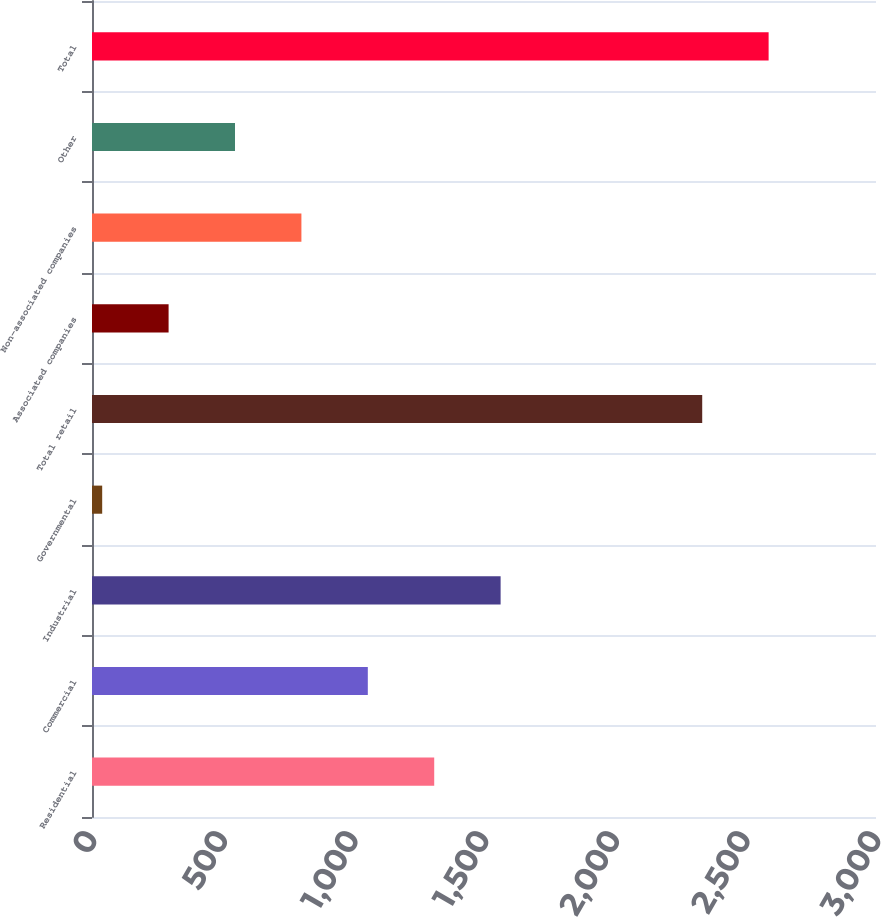<chart> <loc_0><loc_0><loc_500><loc_500><bar_chart><fcel>Residential<fcel>Commercial<fcel>Industrial<fcel>Governmental<fcel>Total retail<fcel>Associated companies<fcel>Non-associated companies<fcel>Other<fcel>Total<nl><fcel>1309.5<fcel>1055.4<fcel>1563.6<fcel>39<fcel>2335<fcel>293.1<fcel>801.3<fcel>547.2<fcel>2589.1<nl></chart> 